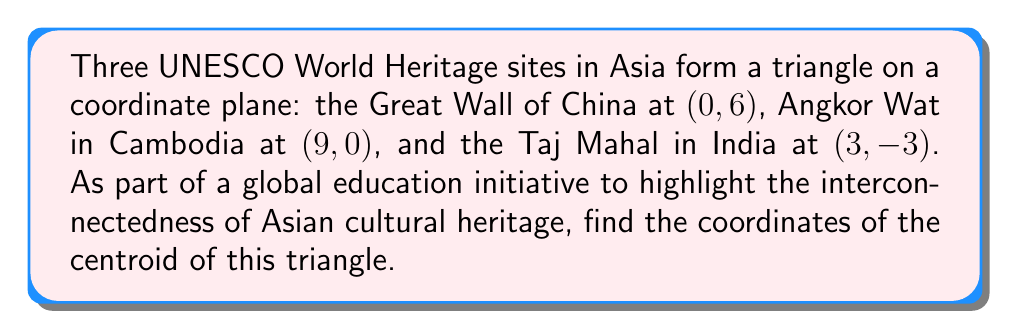Show me your answer to this math problem. To find the centroid of a triangle, we need to follow these steps:

1. Recall that the centroid of a triangle is located at the intersection of its medians, and its coordinates are the arithmetic mean of the coordinates of the triangle's vertices.

2. Let's denote the coordinates of the three points as follows:
   Great Wall of China: $A(0, 6)$
   Angkor Wat: $B(9, 0)$
   Taj Mahal: $C(3, -3)$

3. The formula for the centroid $(x_c, y_c)$ is:

   $$x_c = \frac{x_A + x_B + x_C}{3}$$
   $$y_c = \frac{y_A + y_B + y_C}{3}$$

4. Substituting the given coordinates:

   $$x_c = \frac{0 + 9 + 3}{3} = \frac{12}{3} = 4$$
   $$y_c = \frac{6 + 0 + (-3)}{3} = \frac{3}{3} = 1$$

5. Therefore, the coordinates of the centroid are (4, 1).

This result symbolically represents the average location of these three significant Asian cultural sites, emphasizing their collective importance in global heritage.

[asy]
unitsize(1cm);
pair A = (0,6), B = (9,0), C = (3,-3), G = (4,1);
draw(A--B--C--cycle, black);
dot(A); dot(B); dot(C); dot(G);
label("A (0, 6)", A, N);
label("B (9, 0)", B, SE);
label("C (3, -3)", C, SW);
label("G (4, 1)", G, NE);
[/asy]
Answer: The coordinates of the centroid are (4, 1). 